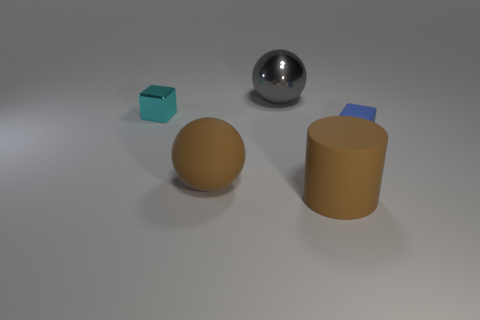Add 2 small matte things. How many objects exist? 7 Subtract all cylinders. How many objects are left? 4 Subtract all balls. Subtract all tiny cyan things. How many objects are left? 2 Add 5 big metallic balls. How many big metallic balls are left? 6 Add 3 brown metallic things. How many brown metallic things exist? 3 Subtract 0 purple cubes. How many objects are left? 5 